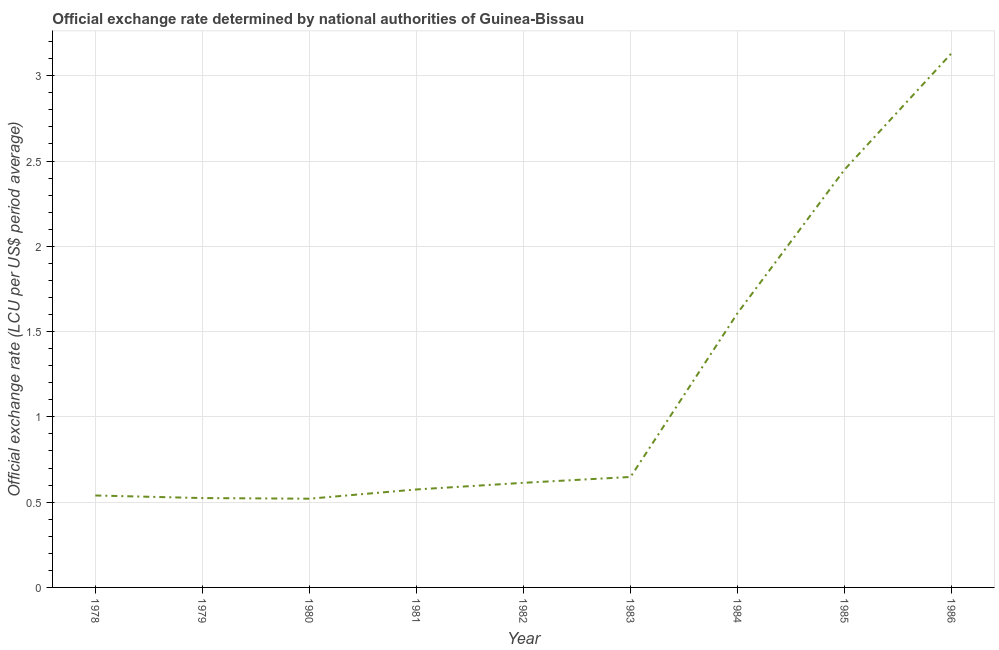What is the official exchange rate in 1979?
Your response must be concise. 0.52. Across all years, what is the maximum official exchange rate?
Give a very brief answer. 3.13. Across all years, what is the minimum official exchange rate?
Your answer should be compact. 0.52. In which year was the official exchange rate minimum?
Your response must be concise. 1980. What is the sum of the official exchange rate?
Ensure brevity in your answer.  10.61. What is the difference between the official exchange rate in 1978 and 1979?
Provide a short and direct response. 0.02. What is the average official exchange rate per year?
Offer a terse response. 1.18. What is the median official exchange rate?
Ensure brevity in your answer.  0.61. In how many years, is the official exchange rate greater than 0.1 ?
Offer a terse response. 9. Do a majority of the years between 1981 and 1980 (inclusive) have official exchange rate greater than 1.3 ?
Offer a very short reply. No. What is the ratio of the official exchange rate in 1978 to that in 1980?
Your answer should be compact. 1.04. Is the official exchange rate in 1979 less than that in 1983?
Your answer should be compact. Yes. What is the difference between the highest and the second highest official exchange rate?
Your response must be concise. 0.68. What is the difference between the highest and the lowest official exchange rate?
Provide a short and direct response. 2.61. Does the official exchange rate monotonically increase over the years?
Offer a terse response. No. How many lines are there?
Offer a very short reply. 1. Does the graph contain any zero values?
Provide a succinct answer. No. Does the graph contain grids?
Provide a short and direct response. Yes. What is the title of the graph?
Your answer should be very brief. Official exchange rate determined by national authorities of Guinea-Bissau. What is the label or title of the X-axis?
Offer a very short reply. Year. What is the label or title of the Y-axis?
Give a very brief answer. Official exchange rate (LCU per US$ period average). What is the Official exchange rate (LCU per US$ period average) of 1978?
Your response must be concise. 0.54. What is the Official exchange rate (LCU per US$ period average) of 1979?
Make the answer very short. 0.52. What is the Official exchange rate (LCU per US$ period average) of 1980?
Give a very brief answer. 0.52. What is the Official exchange rate (LCU per US$ period average) in 1981?
Your answer should be very brief. 0.57. What is the Official exchange rate (LCU per US$ period average) in 1982?
Offer a terse response. 0.61. What is the Official exchange rate (LCU per US$ period average) in 1983?
Provide a short and direct response. 0.65. What is the Official exchange rate (LCU per US$ period average) of 1984?
Keep it short and to the point. 1.61. What is the Official exchange rate (LCU per US$ period average) in 1985?
Your answer should be very brief. 2.45. What is the Official exchange rate (LCU per US$ period average) of 1986?
Provide a short and direct response. 3.13. What is the difference between the Official exchange rate (LCU per US$ period average) in 1978 and 1979?
Offer a very short reply. 0.02. What is the difference between the Official exchange rate (LCU per US$ period average) in 1978 and 1980?
Ensure brevity in your answer.  0.02. What is the difference between the Official exchange rate (LCU per US$ period average) in 1978 and 1981?
Provide a succinct answer. -0.04. What is the difference between the Official exchange rate (LCU per US$ period average) in 1978 and 1982?
Provide a succinct answer. -0.07. What is the difference between the Official exchange rate (LCU per US$ period average) in 1978 and 1983?
Provide a short and direct response. -0.11. What is the difference between the Official exchange rate (LCU per US$ period average) in 1978 and 1984?
Your answer should be compact. -1.07. What is the difference between the Official exchange rate (LCU per US$ period average) in 1978 and 1985?
Offer a terse response. -1.91. What is the difference between the Official exchange rate (LCU per US$ period average) in 1978 and 1986?
Make the answer very short. -2.59. What is the difference between the Official exchange rate (LCU per US$ period average) in 1979 and 1980?
Offer a terse response. 0. What is the difference between the Official exchange rate (LCU per US$ period average) in 1979 and 1981?
Your answer should be compact. -0.05. What is the difference between the Official exchange rate (LCU per US$ period average) in 1979 and 1982?
Provide a succinct answer. -0.09. What is the difference between the Official exchange rate (LCU per US$ period average) in 1979 and 1983?
Make the answer very short. -0.12. What is the difference between the Official exchange rate (LCU per US$ period average) in 1979 and 1984?
Your response must be concise. -1.08. What is the difference between the Official exchange rate (LCU per US$ period average) in 1979 and 1985?
Provide a succinct answer. -1.93. What is the difference between the Official exchange rate (LCU per US$ period average) in 1979 and 1986?
Offer a very short reply. -2.61. What is the difference between the Official exchange rate (LCU per US$ period average) in 1980 and 1981?
Ensure brevity in your answer.  -0.05. What is the difference between the Official exchange rate (LCU per US$ period average) in 1980 and 1982?
Offer a terse response. -0.09. What is the difference between the Official exchange rate (LCU per US$ period average) in 1980 and 1983?
Your response must be concise. -0.13. What is the difference between the Official exchange rate (LCU per US$ period average) in 1980 and 1984?
Provide a short and direct response. -1.09. What is the difference between the Official exchange rate (LCU per US$ period average) in 1980 and 1985?
Give a very brief answer. -1.93. What is the difference between the Official exchange rate (LCU per US$ period average) in 1980 and 1986?
Your answer should be very brief. -2.61. What is the difference between the Official exchange rate (LCU per US$ period average) in 1981 and 1982?
Keep it short and to the point. -0.04. What is the difference between the Official exchange rate (LCU per US$ period average) in 1981 and 1983?
Make the answer very short. -0.07. What is the difference between the Official exchange rate (LCU per US$ period average) in 1981 and 1984?
Ensure brevity in your answer.  -1.03. What is the difference between the Official exchange rate (LCU per US$ period average) in 1981 and 1985?
Ensure brevity in your answer.  -1.88. What is the difference between the Official exchange rate (LCU per US$ period average) in 1981 and 1986?
Your answer should be compact. -2.56. What is the difference between the Official exchange rate (LCU per US$ period average) in 1982 and 1983?
Provide a short and direct response. -0.03. What is the difference between the Official exchange rate (LCU per US$ period average) in 1982 and 1984?
Offer a terse response. -1. What is the difference between the Official exchange rate (LCU per US$ period average) in 1982 and 1985?
Your answer should be compact. -1.84. What is the difference between the Official exchange rate (LCU per US$ period average) in 1982 and 1986?
Ensure brevity in your answer.  -2.52. What is the difference between the Official exchange rate (LCU per US$ period average) in 1983 and 1984?
Your answer should be compact. -0.96. What is the difference between the Official exchange rate (LCU per US$ period average) in 1983 and 1985?
Offer a terse response. -1.8. What is the difference between the Official exchange rate (LCU per US$ period average) in 1983 and 1986?
Give a very brief answer. -2.49. What is the difference between the Official exchange rate (LCU per US$ period average) in 1984 and 1985?
Give a very brief answer. -0.84. What is the difference between the Official exchange rate (LCU per US$ period average) in 1984 and 1986?
Your answer should be compact. -1.52. What is the difference between the Official exchange rate (LCU per US$ period average) in 1985 and 1986?
Offer a terse response. -0.68. What is the ratio of the Official exchange rate (LCU per US$ period average) in 1978 to that in 1979?
Ensure brevity in your answer.  1.03. What is the ratio of the Official exchange rate (LCU per US$ period average) in 1978 to that in 1980?
Your response must be concise. 1.04. What is the ratio of the Official exchange rate (LCU per US$ period average) in 1978 to that in 1981?
Make the answer very short. 0.94. What is the ratio of the Official exchange rate (LCU per US$ period average) in 1978 to that in 1982?
Your answer should be compact. 0.88. What is the ratio of the Official exchange rate (LCU per US$ period average) in 1978 to that in 1983?
Your answer should be very brief. 0.83. What is the ratio of the Official exchange rate (LCU per US$ period average) in 1978 to that in 1984?
Your answer should be compact. 0.34. What is the ratio of the Official exchange rate (LCU per US$ period average) in 1978 to that in 1985?
Your answer should be very brief. 0.22. What is the ratio of the Official exchange rate (LCU per US$ period average) in 1978 to that in 1986?
Offer a terse response. 0.17. What is the ratio of the Official exchange rate (LCU per US$ period average) in 1979 to that in 1980?
Provide a short and direct response. 1.01. What is the ratio of the Official exchange rate (LCU per US$ period average) in 1979 to that in 1981?
Give a very brief answer. 0.91. What is the ratio of the Official exchange rate (LCU per US$ period average) in 1979 to that in 1982?
Provide a succinct answer. 0.85. What is the ratio of the Official exchange rate (LCU per US$ period average) in 1979 to that in 1983?
Make the answer very short. 0.81. What is the ratio of the Official exchange rate (LCU per US$ period average) in 1979 to that in 1984?
Offer a very short reply. 0.33. What is the ratio of the Official exchange rate (LCU per US$ period average) in 1979 to that in 1985?
Ensure brevity in your answer.  0.21. What is the ratio of the Official exchange rate (LCU per US$ period average) in 1979 to that in 1986?
Provide a short and direct response. 0.17. What is the ratio of the Official exchange rate (LCU per US$ period average) in 1980 to that in 1981?
Keep it short and to the point. 0.91. What is the ratio of the Official exchange rate (LCU per US$ period average) in 1980 to that in 1982?
Offer a very short reply. 0.85. What is the ratio of the Official exchange rate (LCU per US$ period average) in 1980 to that in 1983?
Ensure brevity in your answer.  0.8. What is the ratio of the Official exchange rate (LCU per US$ period average) in 1980 to that in 1984?
Provide a succinct answer. 0.32. What is the ratio of the Official exchange rate (LCU per US$ period average) in 1980 to that in 1985?
Offer a very short reply. 0.21. What is the ratio of the Official exchange rate (LCU per US$ period average) in 1980 to that in 1986?
Your answer should be very brief. 0.17. What is the ratio of the Official exchange rate (LCU per US$ period average) in 1981 to that in 1982?
Provide a short and direct response. 0.94. What is the ratio of the Official exchange rate (LCU per US$ period average) in 1981 to that in 1983?
Your answer should be compact. 0.89. What is the ratio of the Official exchange rate (LCU per US$ period average) in 1981 to that in 1984?
Provide a succinct answer. 0.36. What is the ratio of the Official exchange rate (LCU per US$ period average) in 1981 to that in 1985?
Keep it short and to the point. 0.23. What is the ratio of the Official exchange rate (LCU per US$ period average) in 1981 to that in 1986?
Provide a short and direct response. 0.18. What is the ratio of the Official exchange rate (LCU per US$ period average) in 1982 to that in 1983?
Your response must be concise. 0.95. What is the ratio of the Official exchange rate (LCU per US$ period average) in 1982 to that in 1984?
Keep it short and to the point. 0.38. What is the ratio of the Official exchange rate (LCU per US$ period average) in 1982 to that in 1985?
Your response must be concise. 0.25. What is the ratio of the Official exchange rate (LCU per US$ period average) in 1982 to that in 1986?
Give a very brief answer. 0.2. What is the ratio of the Official exchange rate (LCU per US$ period average) in 1983 to that in 1984?
Keep it short and to the point. 0.4. What is the ratio of the Official exchange rate (LCU per US$ period average) in 1983 to that in 1985?
Make the answer very short. 0.26. What is the ratio of the Official exchange rate (LCU per US$ period average) in 1983 to that in 1986?
Provide a succinct answer. 0.21. What is the ratio of the Official exchange rate (LCU per US$ period average) in 1984 to that in 1985?
Offer a terse response. 0.66. What is the ratio of the Official exchange rate (LCU per US$ period average) in 1984 to that in 1986?
Offer a terse response. 0.51. What is the ratio of the Official exchange rate (LCU per US$ period average) in 1985 to that in 1986?
Offer a very short reply. 0.78. 